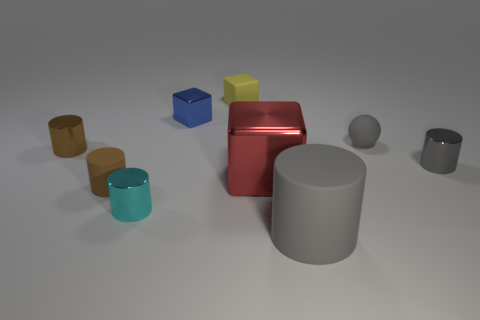What is the size of the rubber cylinder that is the same color as the matte sphere?
Your answer should be very brief. Large. How many objects are large red rubber cylinders or small blue cubes?
Ensure brevity in your answer.  1. What is the material of the gray cylinder that is in front of the brown cylinder in front of the red block?
Ensure brevity in your answer.  Rubber. Is there a thing of the same color as the matte sphere?
Offer a very short reply. Yes. There is a shiny block that is the same size as the rubber ball; what color is it?
Your response must be concise. Blue. What material is the gray thing in front of the small brown cylinder in front of the tiny thing that is to the left of the tiny brown rubber cylinder?
Keep it short and to the point. Rubber. Do the tiny sphere and the matte thing that is in front of the small matte cylinder have the same color?
Offer a very short reply. Yes. What number of things are rubber objects in front of the red metal cube or things right of the blue thing?
Provide a short and direct response. 6. What shape is the matte thing that is left of the small object that is behind the tiny metal cube?
Provide a succinct answer. Cylinder. Are there any small objects made of the same material as the sphere?
Your answer should be very brief. Yes. 